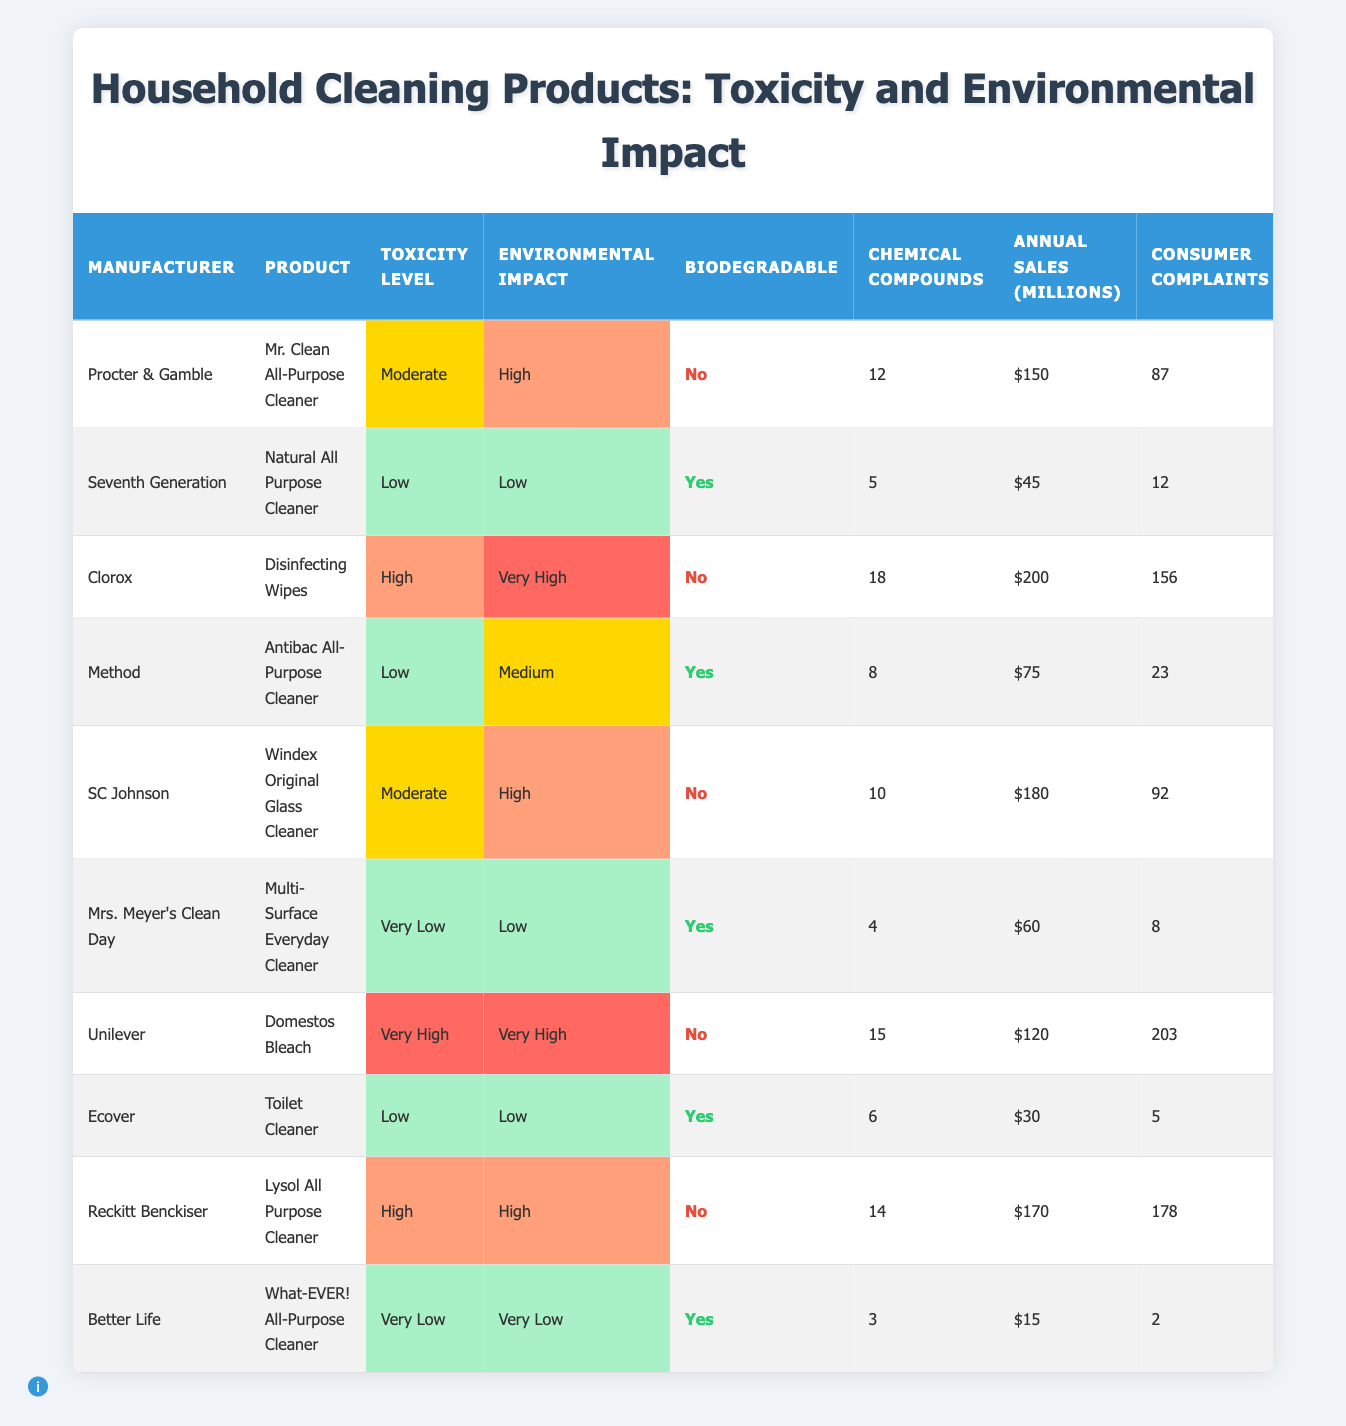What is the toxicity level of Mrs. Meyer's Clean Day Multi-Surface Everyday Cleaner? The table lists "Mrs. Meyer's Clean Day" under the Manufacturer column, and in the corresponding Toxicity Level column, it states "Very Low."
Answer: Very Low Which product has the highest number of consumer complaints? By checking the Consumer Complaints column, "Unilever" with "Domestos Bleach" has the highest complaints at 203.
Answer: 203 Is the Windex Original Glass Cleaner biodegradable? The Biodegradable column indicates that “Windex Original Glass Cleaner” from SC Johnson is listed as "No," meaning it is not biodegradable.
Answer: No How many products are classified as having a "Low" toxicity level? Looking at the Toxicity Level column, the products with "Low" toxicity are "Natural All Purpose Cleaner," "Antibac All-Purpose Cleaner," "Toilet Cleaner," and two with "Very Low." This makes a total of 5 products classified as Low toxicity.
Answer: 5 What is the environmental impact level of the Clorox Disinfecting Wipes? The Environmental Impact column shows that "Clorox" with "Disinfecting Wipes" has a "Very High" environmental impact.
Answer: Very High Which manufacturer has the most annual sales, and what is the amount? Scanning through the Annual Sales column, "Clorox" tops the list with $200 million in annual sales.
Answer: $200 million Are all the products from manufacturers with high toxicity biodegradable? By examining the Biodegradable column for products with high toxicity levels such as Clorox and Reckitt Benckiser, both are marked "No." Therefore, not all high toxicity products are biodegradable.
Answer: No What is the average number of chemical compounds in the products with a "Moderate" toxicity level? The products with "Moderate" toxicity are Mr. Clean with 12 compounds and Windex with 10 compounds. Average = (12 + 10) / 2 = 11.
Answer: 11 How many products are both biodegradable and have a low environmental impact? Checking both the Biodegradable and Environmental Impact columns, the products that are "Yes" for biodegradable and "Low" for environmental impact are "Natural All Purpose Cleaner” and "Toilet Cleaner," making a total of 2.
Answer: 2 